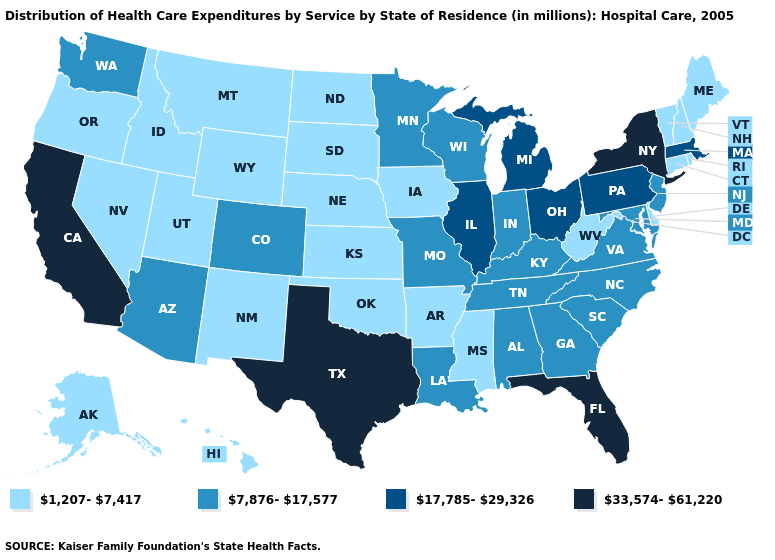Does New Hampshire have the lowest value in the USA?
Be succinct. Yes. What is the value of Delaware?
Short answer required. 1,207-7,417. Among the states that border Texas , which have the lowest value?
Write a very short answer. Arkansas, New Mexico, Oklahoma. What is the lowest value in states that border Minnesota?
Be succinct. 1,207-7,417. What is the value of Pennsylvania?
Keep it brief. 17,785-29,326. What is the value of Florida?
Keep it brief. 33,574-61,220. What is the value of Delaware?
Concise answer only. 1,207-7,417. Name the states that have a value in the range 17,785-29,326?
Answer briefly. Illinois, Massachusetts, Michigan, Ohio, Pennsylvania. What is the highest value in states that border Pennsylvania?
Concise answer only. 33,574-61,220. Among the states that border Colorado , does Arizona have the highest value?
Write a very short answer. Yes. What is the highest value in states that border Massachusetts?
Answer briefly. 33,574-61,220. Name the states that have a value in the range 33,574-61,220?
Quick response, please. California, Florida, New York, Texas. Name the states that have a value in the range 33,574-61,220?
Quick response, please. California, Florida, New York, Texas. Does Ohio have the highest value in the MidWest?
Be succinct. Yes. 